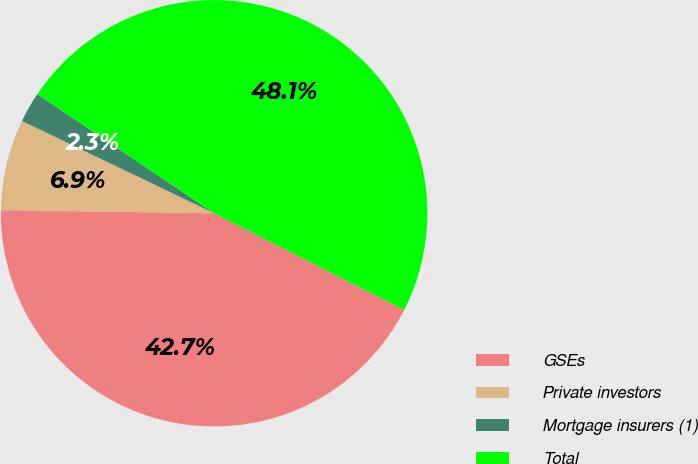<chart> <loc_0><loc_0><loc_500><loc_500><pie_chart><fcel>GSEs<fcel>Private investors<fcel>Mortgage insurers (1)<fcel>Total<nl><fcel>42.74%<fcel>6.89%<fcel>2.31%<fcel>48.05%<nl></chart> 